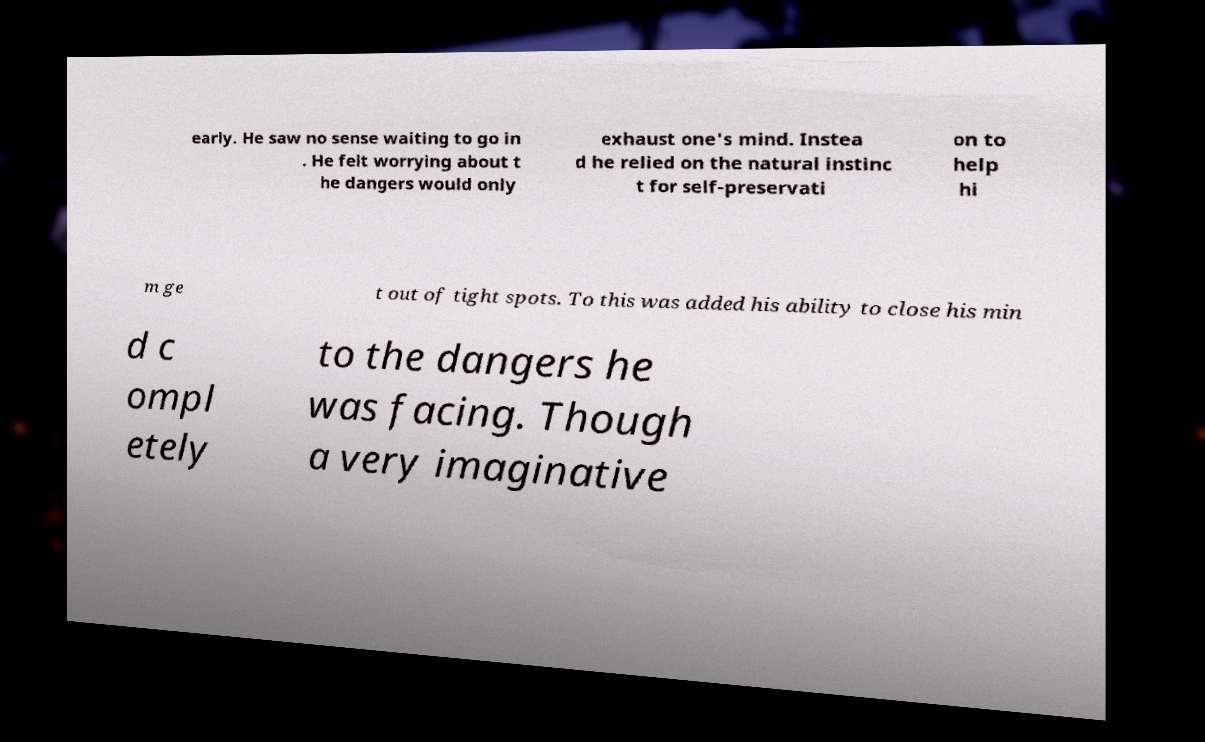Can you accurately transcribe the text from the provided image for me? early. He saw no sense waiting to go in . He felt worrying about t he dangers would only exhaust one's mind. Instea d he relied on the natural instinc t for self-preservati on to help hi m ge t out of tight spots. To this was added his ability to close his min d c ompl etely to the dangers he was facing. Though a very imaginative 